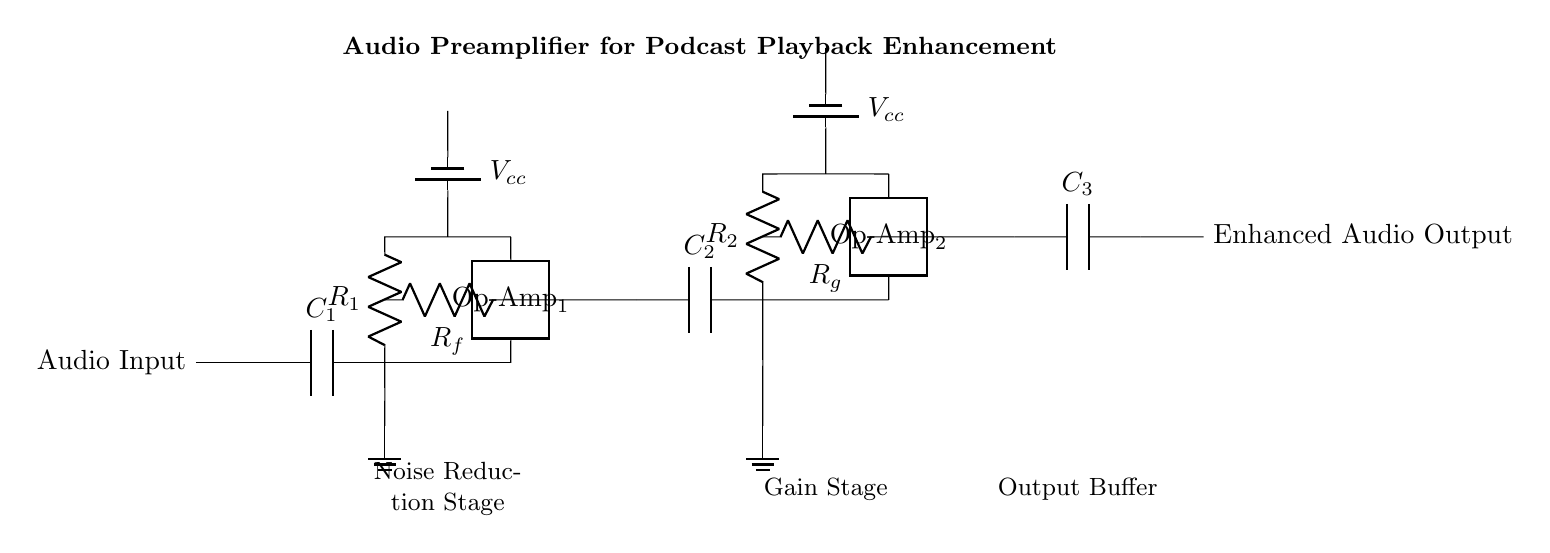What is the purpose of C1? C1 is a coupling capacitor used to block DC voltage while allowing AC signals to pass through, thus isolating the input signal.
Answer: Coupling What are the resistances in the first amplification stage? The resistances in the first stage are R1 and Rf, which are used to control gain and feedback in the operational amplifier.
Answer: R1 and Rf What type of amplifiers are used in this circuit? The circuit employs operational amplifiers, indicated by the twoport symbol and labeled as Op-Amp_1 and Op-Amp_2.
Answer: Operational amplifiers How many stages of amplification are present in this circuit? There are two stages of amplification shown in the circuit, each represented by a separate operational amplifier.
Answer: Two Which component provides power to the circuit? The circuit receives power from batteries labeled as Vcc, which are connected to both operational amplifiers in the design.
Answer: Batteries What is the output connection labeled as? The output of the circuit is labeled as "Enhanced Audio Output," indicating that it is meant for final audio playback enhancement.
Answer: Enhanced Audio Output What is the function of Rg in the second stage? Rg is the feedback resistor in the second amplifier stage, which helps to set the gain of the operational amplifier by determining how much of the output signal is fed back into the input.
Answer: Set gain 